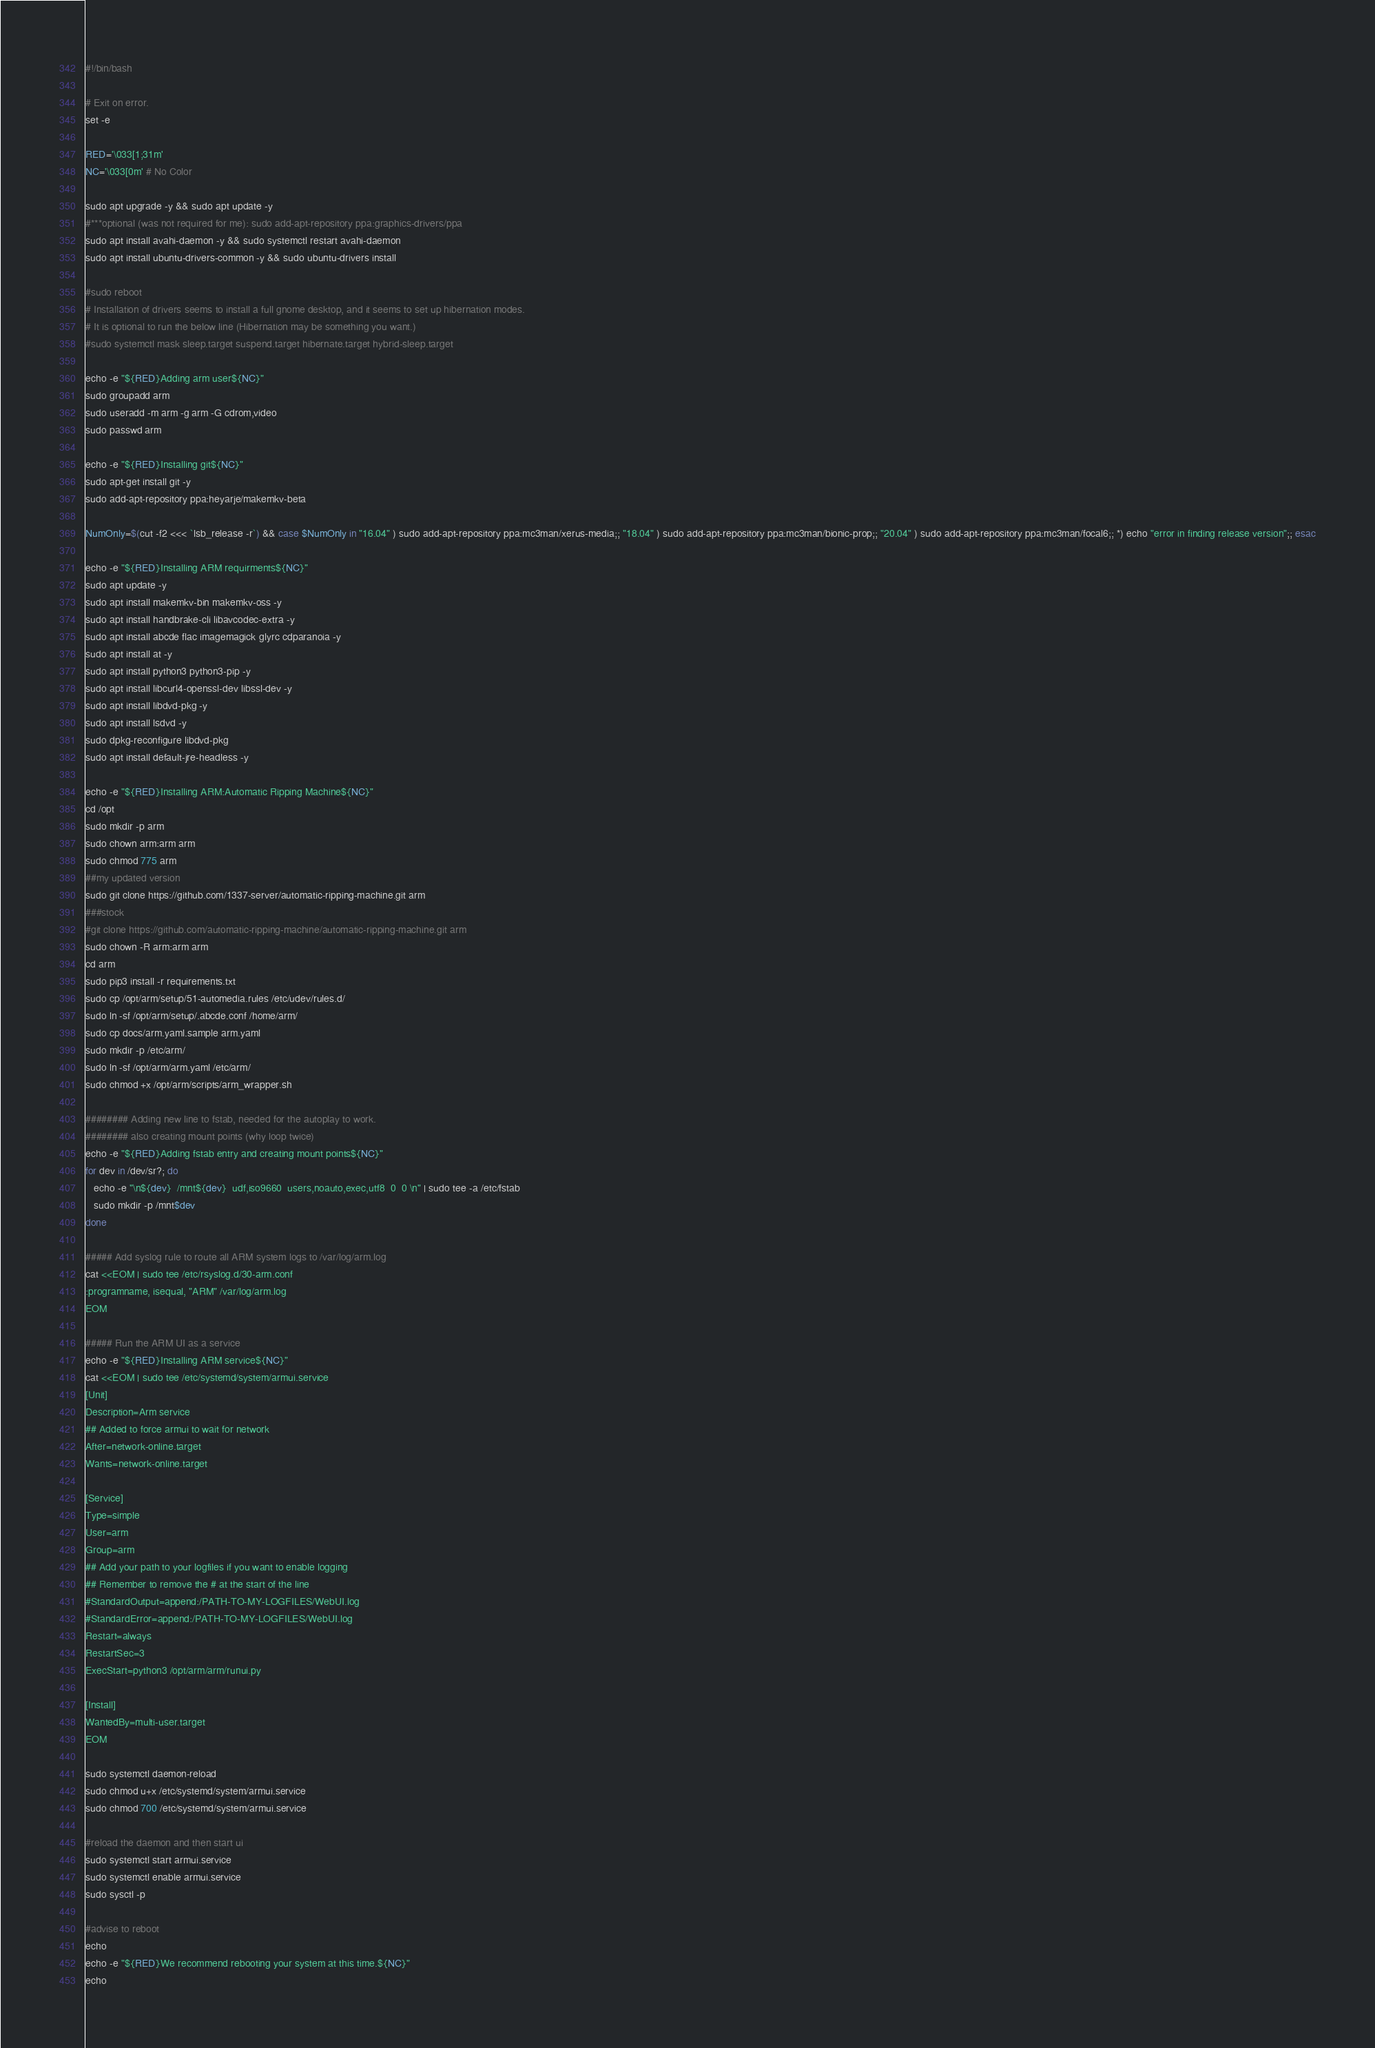Convert code to text. <code><loc_0><loc_0><loc_500><loc_500><_Bash_>#!/bin/bash

# Exit on error.
set -e

RED='\033[1;31m'
NC='\033[0m' # No Color

sudo apt upgrade -y && sudo apt update -y 
#***optional (was not required for me): sudo add-apt-repository ppa:graphics-drivers/ppa
sudo apt install avahi-daemon -y && sudo systemctl restart avahi-daemon
sudo apt install ubuntu-drivers-common -y && sudo ubuntu-drivers install 

#sudo reboot
# Installation of drivers seems to install a full gnome desktop, and it seems to set up hibernation modes.
# It is optional to run the below line (Hibernation may be something you want.)
#sudo systemctl mask sleep.target suspend.target hibernate.target hybrid-sleep.target

echo -e "${RED}Adding arm user${NC}"
sudo groupadd arm
sudo useradd -m arm -g arm -G cdrom,video
sudo passwd arm

echo -e "${RED}Installing git${NC}"
sudo apt-get install git -y
sudo add-apt-repository ppa:heyarje/makemkv-beta

NumOnly=$(cut -f2 <<< `lsb_release -r`) && case $NumOnly in "16.04" ) sudo add-apt-repository ppa:mc3man/xerus-media;; "18.04" ) sudo add-apt-repository ppa:mc3man/bionic-prop;; "20.04" ) sudo add-apt-repository ppa:mc3man/focal6;; *) echo "error in finding release version";; esac

echo -e "${RED}Installing ARM requirments${NC}"
sudo apt update -y
sudo apt install makemkv-bin makemkv-oss -y
sudo apt install handbrake-cli libavcodec-extra -y
sudo apt install abcde flac imagemagick glyrc cdparanoia -y
sudo apt install at -y
sudo apt install python3 python3-pip -y
sudo apt install libcurl4-openssl-dev libssl-dev -y
sudo apt install libdvd-pkg -y
sudo apt install lsdvd -y
sudo dpkg-reconfigure libdvd-pkg
sudo apt install default-jre-headless -y

echo -e "${RED}Installing ARM:Automatic Ripping Machine${NC}"
cd /opt
sudo mkdir -p arm
sudo chown arm:arm arm
sudo chmod 775 arm
##my updated version
sudo git clone https://github.com/1337-server/automatic-ripping-machine.git arm
###stock
#git clone https://github.com/automatic-ripping-machine/automatic-ripping-machine.git arm
sudo chown -R arm:arm arm
cd arm
sudo pip3 install -r requirements.txt 
sudo cp /opt/arm/setup/51-automedia.rules /etc/udev/rules.d/
sudo ln -sf /opt/arm/setup/.abcde.conf /home/arm/
sudo cp docs/arm.yaml.sample arm.yaml
sudo mkdir -p /etc/arm/
sudo ln -sf /opt/arm/arm.yaml /etc/arm/
sudo chmod +x /opt/arm/scripts/arm_wrapper.sh

######## Adding new line to fstab, needed for the autoplay to work.
######## also creating mount points (why loop twice)
echo -e "${RED}Adding fstab entry and creating mount points${NC}"
for dev in /dev/sr?; do
   echo -e "\n${dev}  /mnt${dev}  udf,iso9660  users,noauto,exec,utf8  0  0 \n" | sudo tee -a /etc/fstab
   sudo mkdir -p /mnt$dev
done

##### Add syslog rule to route all ARM system logs to /var/log/arm.log
cat <<EOM | sudo tee /etc/rsyslog.d/30-arm.conf
:programname, isequal, "ARM" /var/log/arm.log
EOM

##### Run the ARM UI as a service
echo -e "${RED}Installing ARM service${NC}"
cat <<EOM | sudo tee /etc/systemd/system/armui.service
[Unit]
Description=Arm service
## Added to force armui to wait for network
After=network-online.target
Wants=network-online.target

[Service]
Type=simple
User=arm
Group=arm
## Add your path to your logfiles if you want to enable logging
## Remember to remove the # at the start of the line
#StandardOutput=append:/PATH-TO-MY-LOGFILES/WebUI.log
#StandardError=append:/PATH-TO-MY-LOGFILES/WebUI.log
Restart=always
RestartSec=3
ExecStart=python3 /opt/arm/arm/runui.py

[Install]
WantedBy=multi-user.target
EOM

sudo systemctl daemon-reload
sudo chmod u+x /etc/systemd/system/armui.service
sudo chmod 700 /etc/systemd/system/armui.service

#reload the daemon and then start ui
sudo systemctl start armui.service 
sudo systemctl enable armui.service
sudo sysctl -p

#advise to reboot
echo
echo -e "${RED}We recommend rebooting your system at this time.${NC}"
echo
</code> 